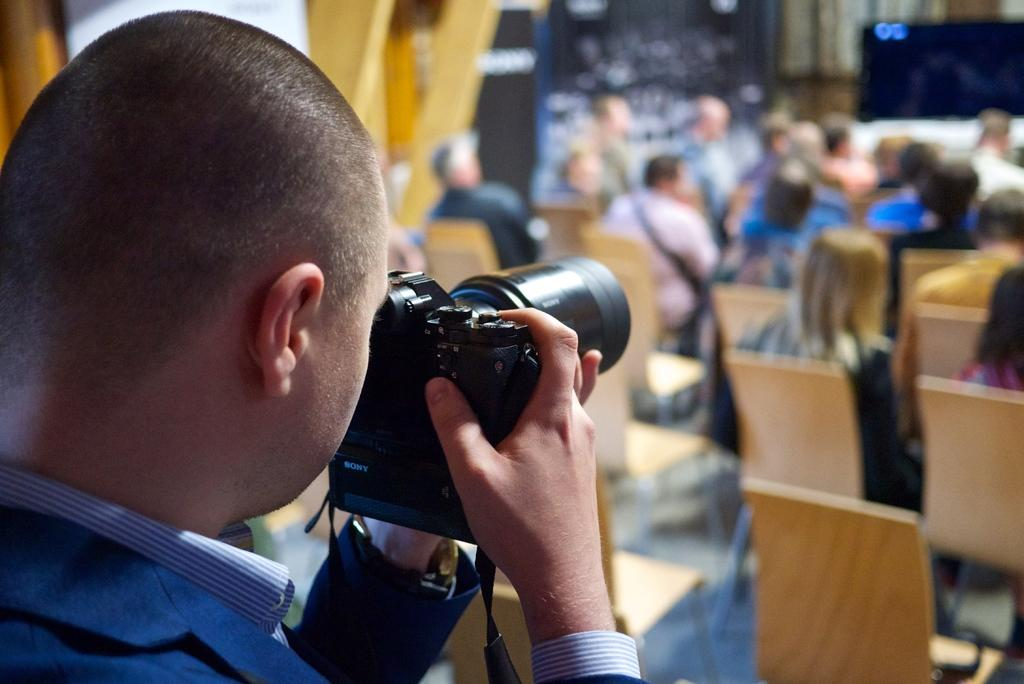What is the person on the left side of the image doing? The person is holding a camera and clicking an image. Can you describe the activity of the person in the image? The person is taking a photograph. What are the other people in the image doing? There are people sitting on chairs in the image. What type of dinosaurs can be seen in the image? There are no dinosaurs present in the image. What fruit is being held by the person in the image? The person is holding a camera, not a pear or any fruit. 